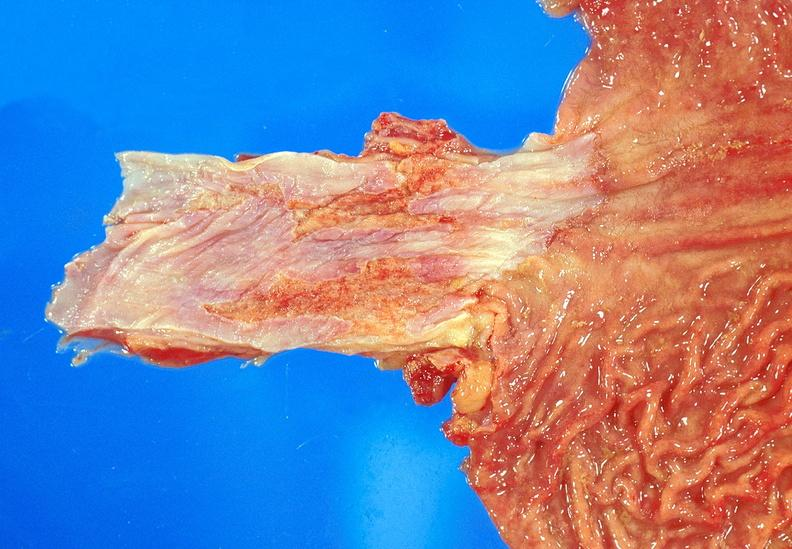s gastrointestinal present?
Answer the question using a single word or phrase. Yes 